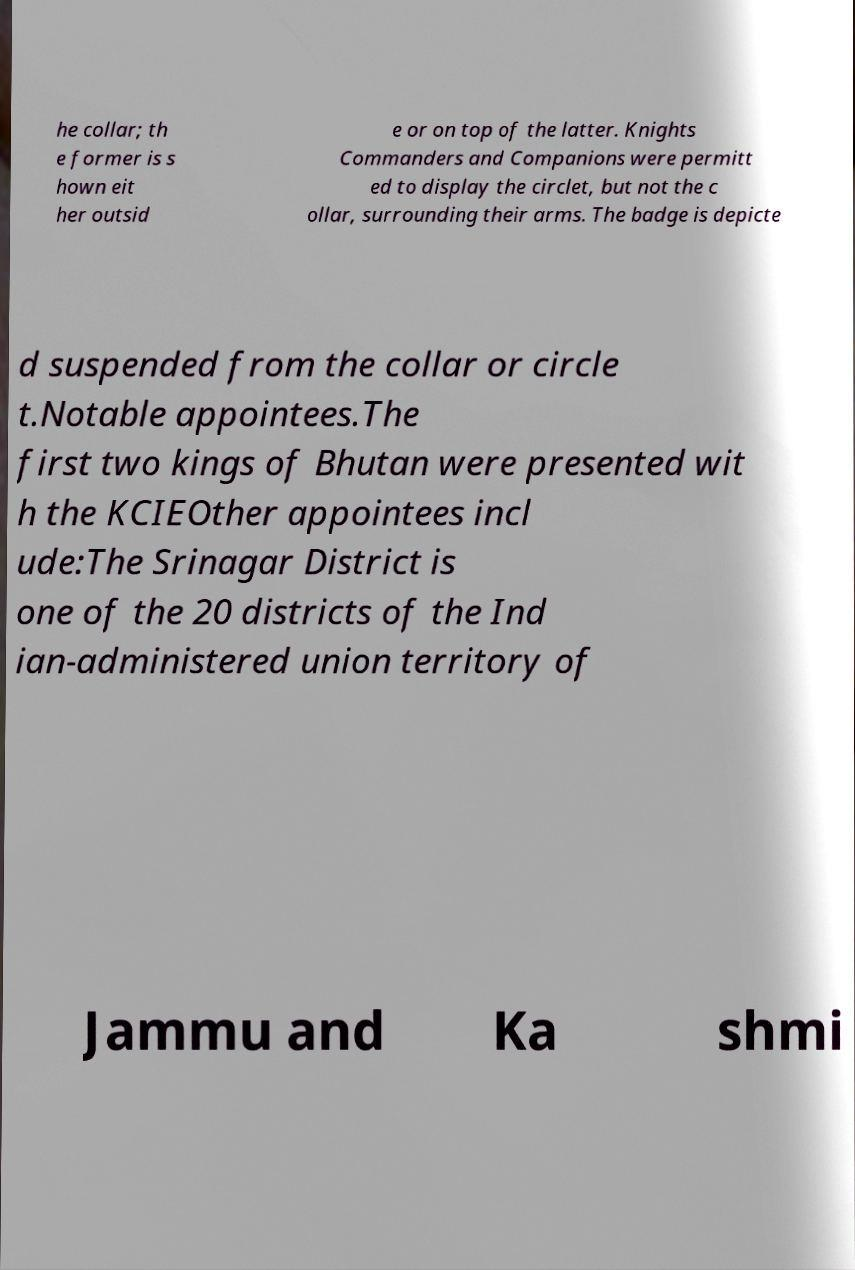Can you accurately transcribe the text from the provided image for me? he collar; th e former is s hown eit her outsid e or on top of the latter. Knights Commanders and Companions were permitt ed to display the circlet, but not the c ollar, surrounding their arms. The badge is depicte d suspended from the collar or circle t.Notable appointees.The first two kings of Bhutan were presented wit h the KCIEOther appointees incl ude:The Srinagar District is one of the 20 districts of the Ind ian-administered union territory of Jammu and Ka shmi 